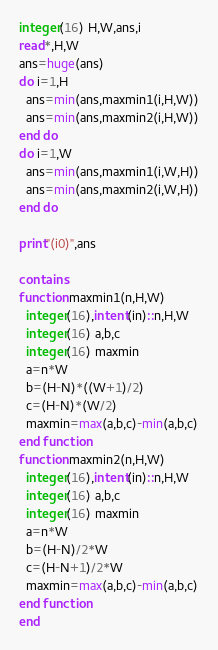Convert code to text. <code><loc_0><loc_0><loc_500><loc_500><_FORTRAN_>integer(16) H,W,ans,i
read*,H,W
ans=huge(ans)
do i=1,H
  ans=min(ans,maxmin1(i,H,W))
  ans=min(ans,maxmin2(i,H,W))
end do
do i=1,W
  ans=min(ans,maxmin1(i,W,H))
  ans=min(ans,maxmin2(i,W,H))
end do

print"(i0)",ans

contains
function maxmin1(n,H,W)
  integer(16),intent(in)::n,H,W
  integer(16) a,b,c
  integer(16) maxmin
  a=n*W
  b=(H-N)*((W+1)/2)
  c=(H-N)*(W/2)
  maxmin=max(a,b,c)-min(a,b,c)
end function
function maxmin2(n,H,W)
  integer(16),intent(in)::n,H,W
  integer(16) a,b,c
  integer(16) maxmin
  a=n*W
  b=(H-N)/2*W
  c=(H-N+1)/2*W
  maxmin=max(a,b,c)-min(a,b,c)
end function
end</code> 